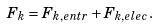<formula> <loc_0><loc_0><loc_500><loc_500>F _ { k } = F _ { k , e n t r } + F _ { k , e l e c } .</formula> 